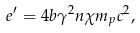Convert formula to latex. <formula><loc_0><loc_0><loc_500><loc_500>e ^ { \prime } = 4 b \gamma ^ { 2 } n \chi m _ { p } c ^ { 2 } ,</formula> 